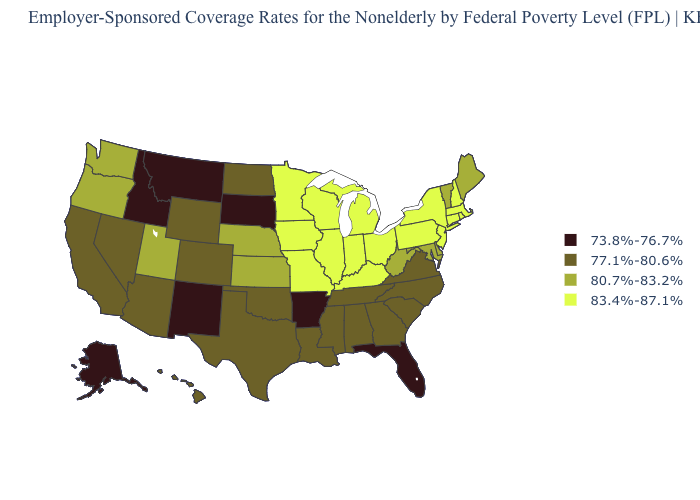Name the states that have a value in the range 80.7%-83.2%?
Write a very short answer. Delaware, Kansas, Maine, Maryland, Nebraska, Oregon, Utah, Vermont, Washington, West Virginia. Name the states that have a value in the range 77.1%-80.6%?
Quick response, please. Alabama, Arizona, California, Colorado, Georgia, Hawaii, Louisiana, Mississippi, Nevada, North Carolina, North Dakota, Oklahoma, South Carolina, Tennessee, Texas, Virginia, Wyoming. What is the value of Iowa?
Give a very brief answer. 83.4%-87.1%. Does South Dakota have the highest value in the MidWest?
Give a very brief answer. No. Does South Dakota have the lowest value in the MidWest?
Write a very short answer. Yes. What is the value of South Dakota?
Write a very short answer. 73.8%-76.7%. What is the value of Montana?
Answer briefly. 73.8%-76.7%. What is the highest value in the South ?
Keep it brief. 83.4%-87.1%. What is the value of Kansas?
Give a very brief answer. 80.7%-83.2%. Does New Hampshire have the highest value in the USA?
Quick response, please. Yes. What is the lowest value in the USA?
Give a very brief answer. 73.8%-76.7%. Does the first symbol in the legend represent the smallest category?
Answer briefly. Yes. Does Illinois have the lowest value in the MidWest?
Quick response, please. No. What is the lowest value in states that border Pennsylvania?
Short answer required. 80.7%-83.2%. 